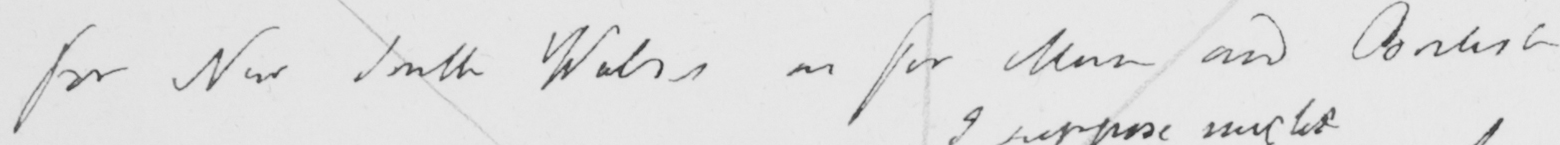Can you read and transcribe this handwriting? for New South Wales as for Man and British 